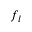<formula> <loc_0><loc_0><loc_500><loc_500>f _ { l }</formula> 